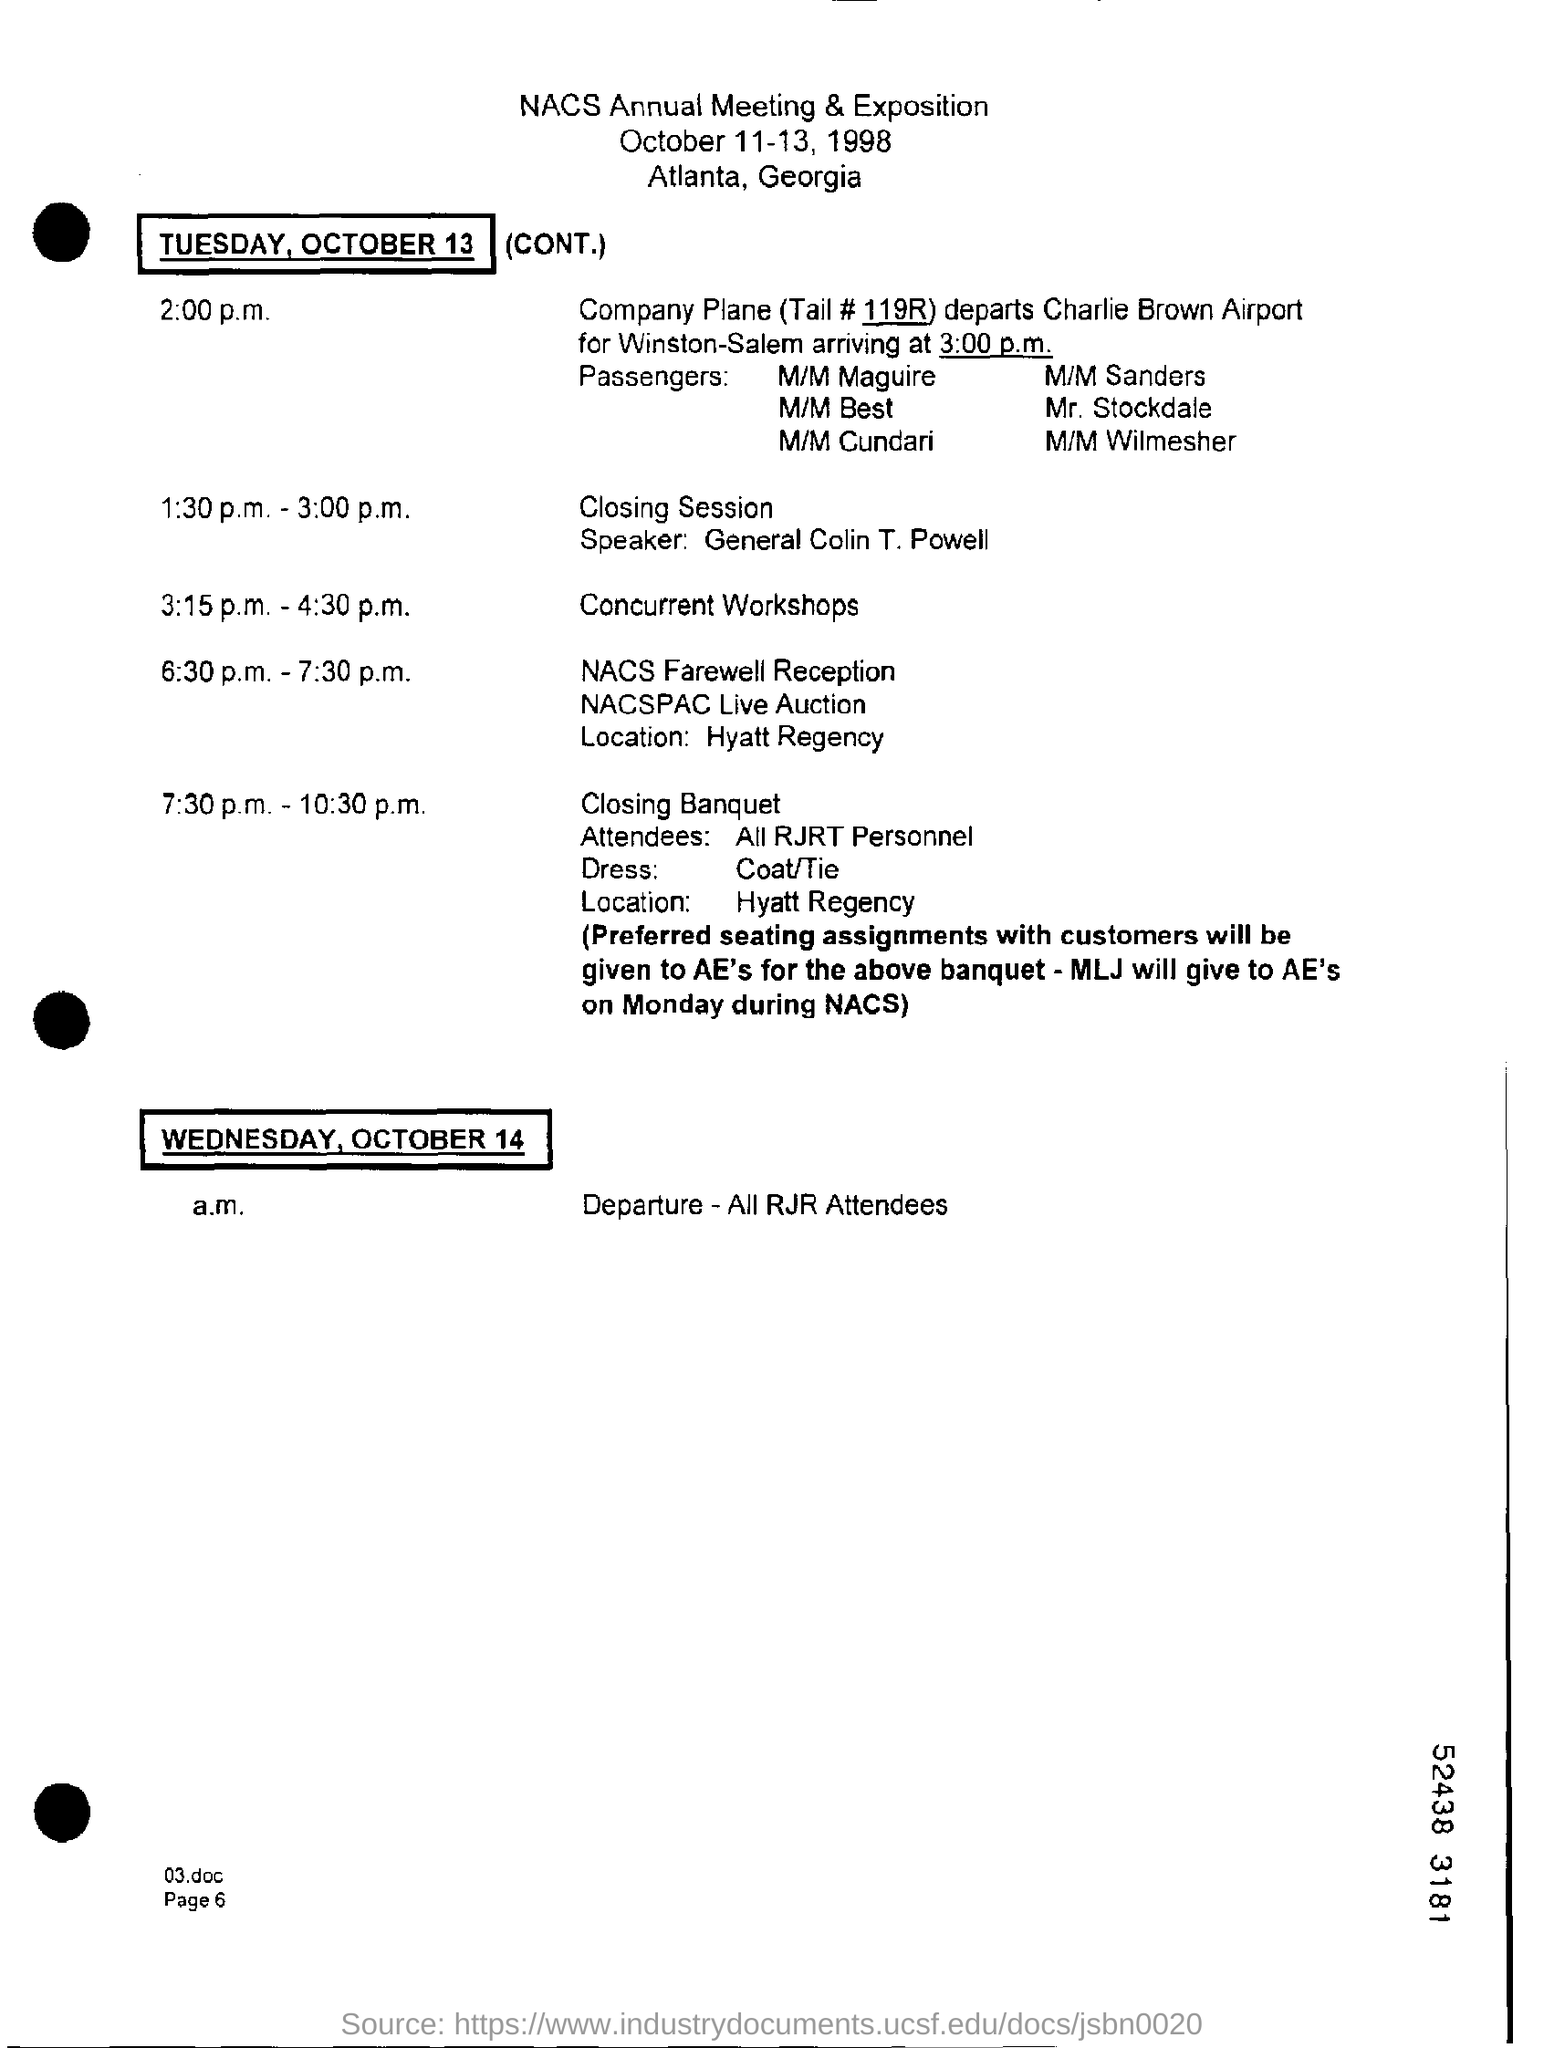When is the NACS Annual Meeting & Exposition held?
Your response must be concise. October 11-13, 1998. Who is the speaker for the closing session?
Your answer should be very brief. General colin t. powell. What time is the concurrent workshops scheduled?
Ensure brevity in your answer.  3:15 p.m. - 4:30 p.m. Where is the NACS Farewell Reception held?
Your answer should be compact. Hyatt regency. What time is the closing banquet scheduled?
Your response must be concise. 7:30 p.m. - 10:30 p.m. What date is the departure of all RJR attendees scheduled?
Provide a short and direct response. Wednesday, October 14. 